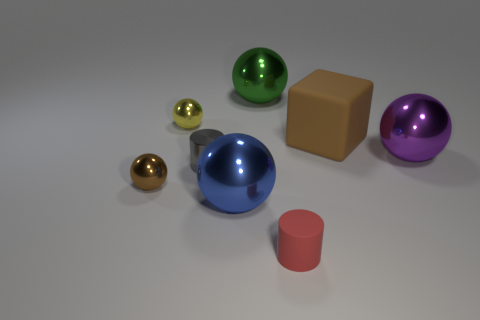Subtract all tiny yellow metallic spheres. How many spheres are left? 4 Subtract all cyan balls. Subtract all gray cylinders. How many balls are left? 5 Add 1 large purple things. How many objects exist? 9 Subtract all spheres. How many objects are left? 3 Subtract 0 red blocks. How many objects are left? 8 Subtract all large cubes. Subtract all small gray things. How many objects are left? 6 Add 1 big green shiny things. How many big green shiny things are left? 2 Add 1 blue metallic things. How many blue metallic things exist? 2 